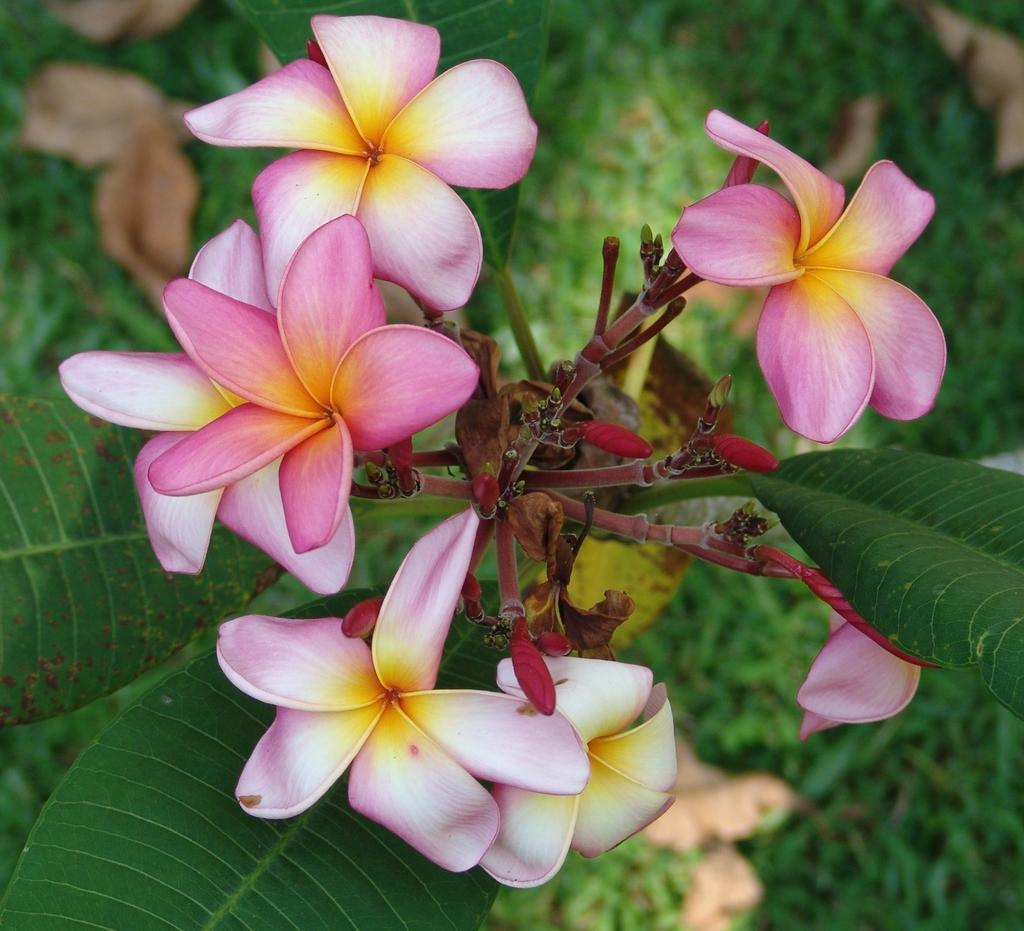How would you summarize this image in a sentence or two? In this image, we can see flowers, stems, flower buds and leaves. Background we can see the blur view. 